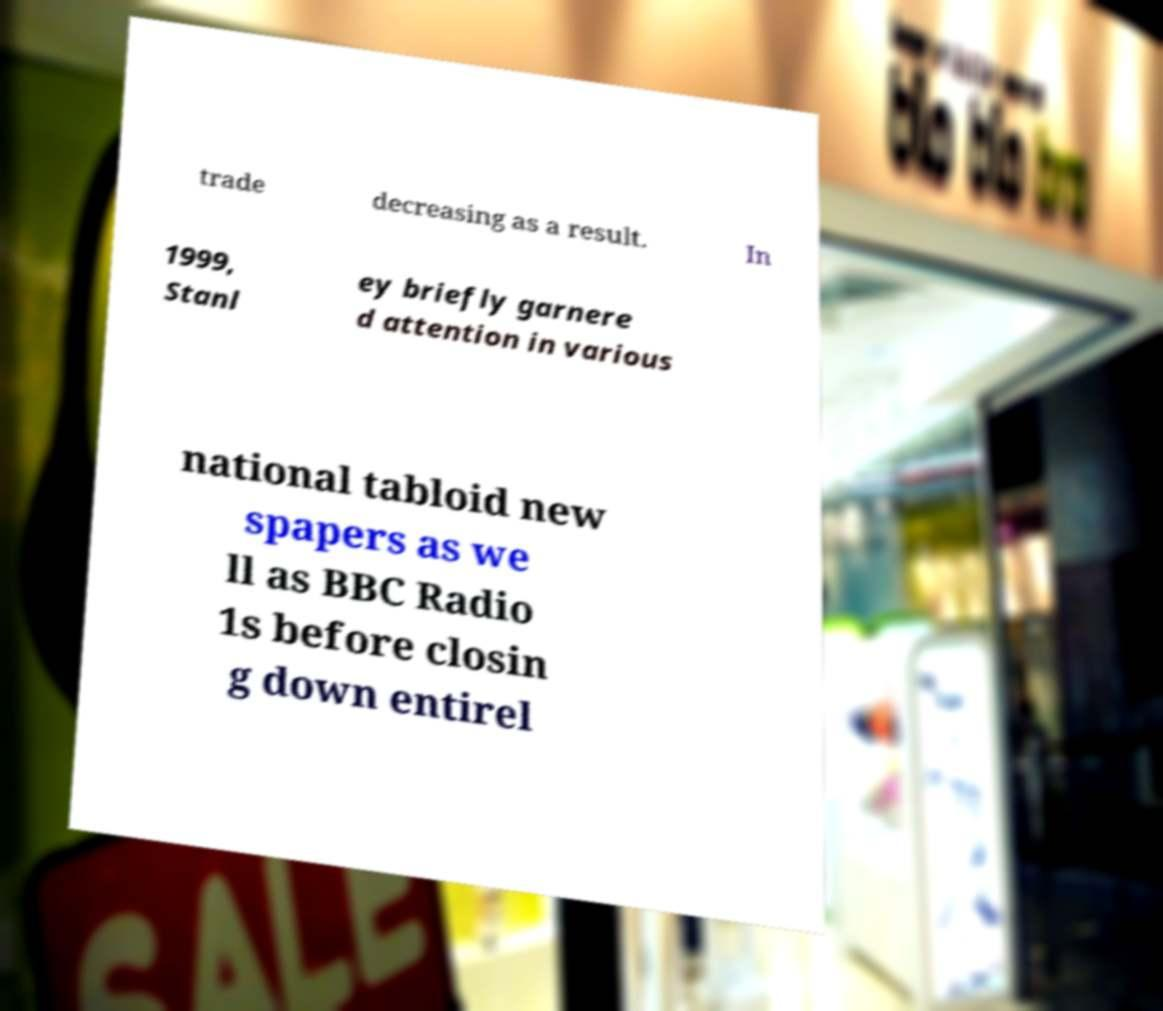Can you accurately transcribe the text from the provided image for me? trade decreasing as a result. In 1999, Stanl ey briefly garnere d attention in various national tabloid new spapers as we ll as BBC Radio 1s before closin g down entirel 